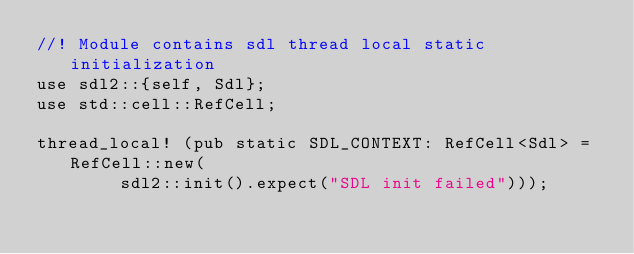Convert code to text. <code><loc_0><loc_0><loc_500><loc_500><_Rust_>//! Module contains sdl thread local static initialization
use sdl2::{self, Sdl};
use std::cell::RefCell;

thread_local! (pub static SDL_CONTEXT: RefCell<Sdl> = RefCell::new(
        sdl2::init().expect("SDL init failed")));
</code> 